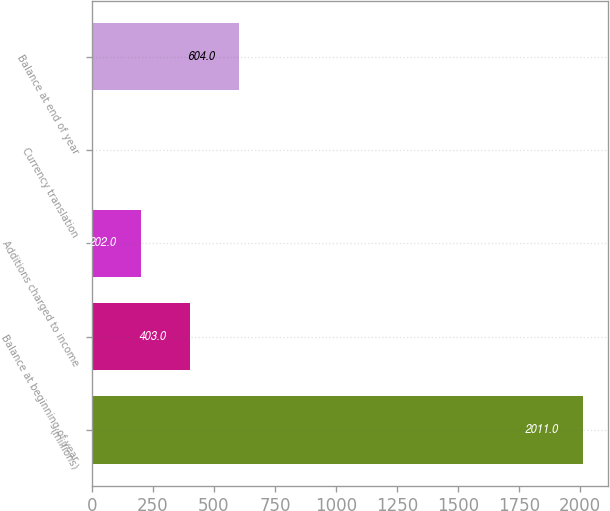Convert chart to OTSL. <chart><loc_0><loc_0><loc_500><loc_500><bar_chart><fcel>(millions)<fcel>Balance at beginning of year<fcel>Additions charged to income<fcel>Currency translation<fcel>Balance at end of year<nl><fcel>2011<fcel>403<fcel>202<fcel>1<fcel>604<nl></chart> 